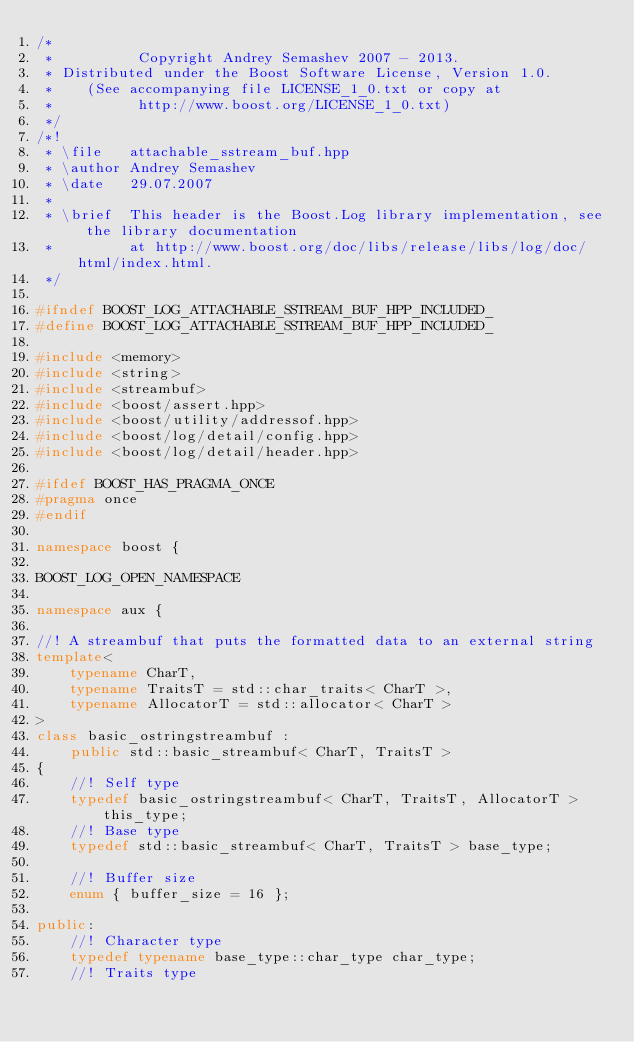<code> <loc_0><loc_0><loc_500><loc_500><_C++_>/*
 *          Copyright Andrey Semashev 2007 - 2013.
 * Distributed under the Boost Software License, Version 1.0.
 *    (See accompanying file LICENSE_1_0.txt or copy at
 *          http://www.boost.org/LICENSE_1_0.txt)
 */
/*!
 * \file   attachable_sstream_buf.hpp
 * \author Andrey Semashev
 * \date   29.07.2007
 *
 * \brief  This header is the Boost.Log library implementation, see the library documentation
 *         at http://www.boost.org/doc/libs/release/libs/log/doc/html/index.html.
 */

#ifndef BOOST_LOG_ATTACHABLE_SSTREAM_BUF_HPP_INCLUDED_
#define BOOST_LOG_ATTACHABLE_SSTREAM_BUF_HPP_INCLUDED_

#include <memory>
#include <string>
#include <streambuf>
#include <boost/assert.hpp>
#include <boost/utility/addressof.hpp>
#include <boost/log/detail/config.hpp>
#include <boost/log/detail/header.hpp>

#ifdef BOOST_HAS_PRAGMA_ONCE
#pragma once
#endif

namespace boost {

BOOST_LOG_OPEN_NAMESPACE

namespace aux {

//! A streambuf that puts the formatted data to an external string
template<
    typename CharT,
    typename TraitsT = std::char_traits< CharT >,
    typename AllocatorT = std::allocator< CharT >
>
class basic_ostringstreambuf :
    public std::basic_streambuf< CharT, TraitsT >
{
    //! Self type
    typedef basic_ostringstreambuf< CharT, TraitsT, AllocatorT > this_type;
    //! Base type
    typedef std::basic_streambuf< CharT, TraitsT > base_type;

    //! Buffer size
    enum { buffer_size = 16 };

public:
    //! Character type
    typedef typename base_type::char_type char_type;
    //! Traits type</code> 